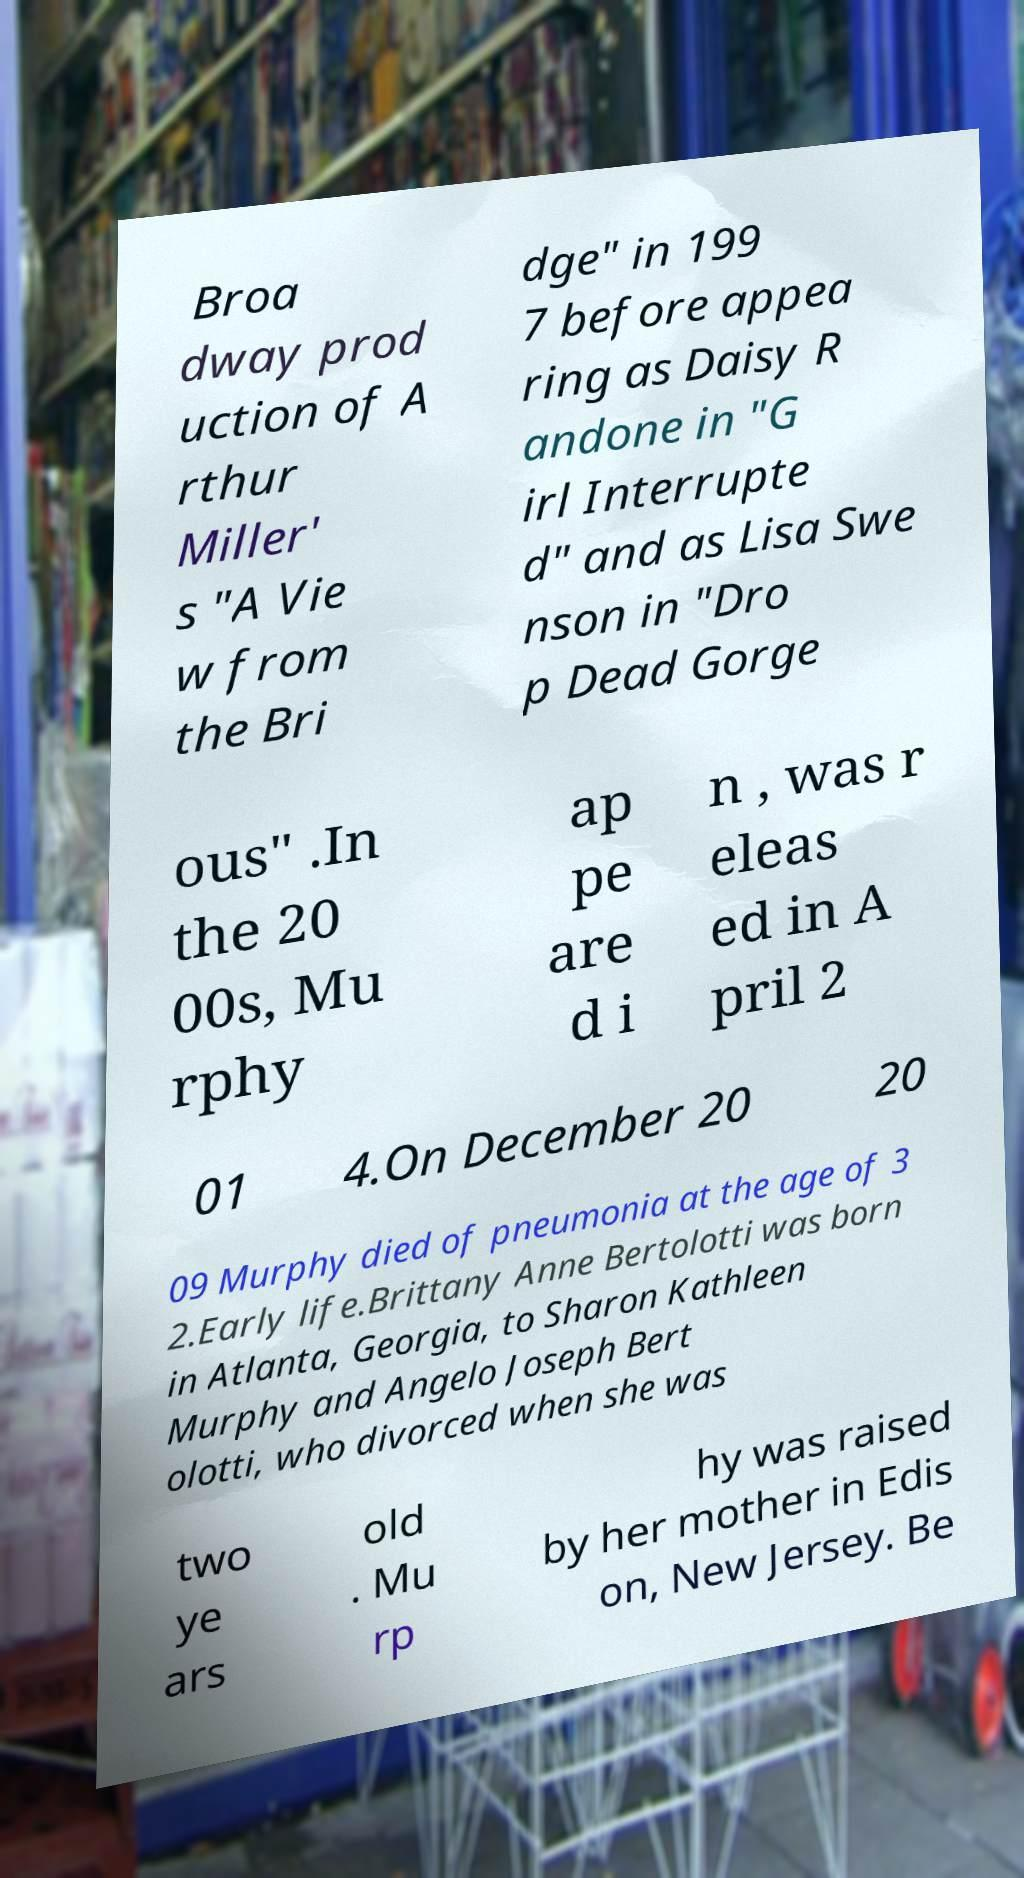Can you read and provide the text displayed in the image?This photo seems to have some interesting text. Can you extract and type it out for me? Broa dway prod uction of A rthur Miller' s "A Vie w from the Bri dge" in 199 7 before appea ring as Daisy R andone in "G irl Interrupte d" and as Lisa Swe nson in "Dro p Dead Gorge ous" .In the 20 00s, Mu rphy ap pe are d i n , was r eleas ed in A pril 2 01 4.On December 20 20 09 Murphy died of pneumonia at the age of 3 2.Early life.Brittany Anne Bertolotti was born in Atlanta, Georgia, to Sharon Kathleen Murphy and Angelo Joseph Bert olotti, who divorced when she was two ye ars old . Mu rp hy was raised by her mother in Edis on, New Jersey. Be 